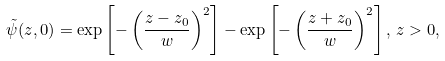<formula> <loc_0><loc_0><loc_500><loc_500>\tilde { \psi } ( z , 0 ) = \exp \left [ - \left ( \frac { z - z _ { 0 } } { w } \right ) ^ { 2 } \right ] - \exp \left [ - \left ( \frac { z + z _ { 0 } } { w } \right ) ^ { 2 } \right ] , \, z > 0 ,</formula> 